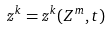Convert formula to latex. <formula><loc_0><loc_0><loc_500><loc_500>z ^ { k } = z ^ { k } ( Z ^ { m } , t )</formula> 